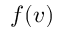<formula> <loc_0><loc_0><loc_500><loc_500>f ( v )</formula> 